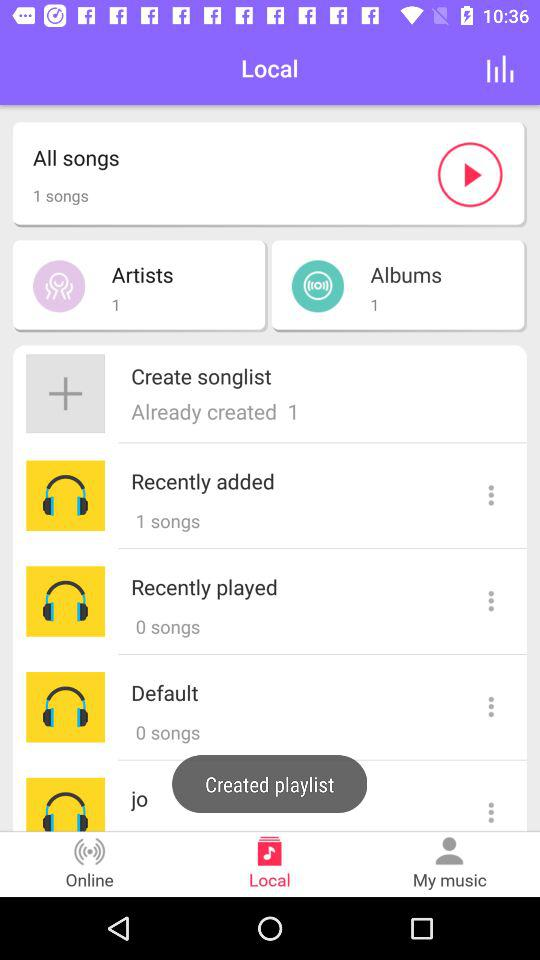How many songs are in the recently added list? There is 1 song in the recently added list. 